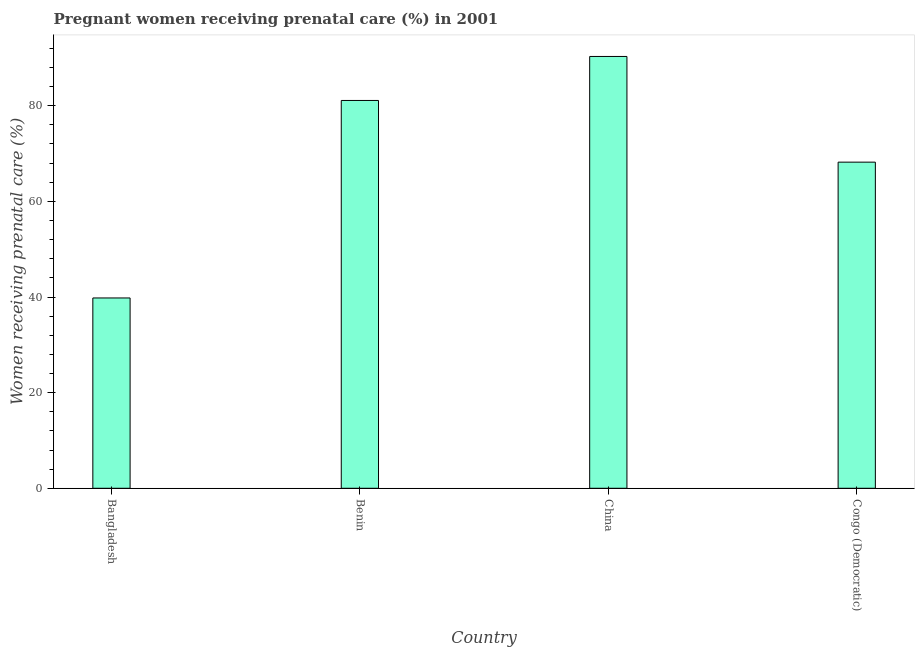What is the title of the graph?
Your response must be concise. Pregnant women receiving prenatal care (%) in 2001. What is the label or title of the X-axis?
Give a very brief answer. Country. What is the label or title of the Y-axis?
Provide a short and direct response. Women receiving prenatal care (%). What is the percentage of pregnant women receiving prenatal care in China?
Provide a succinct answer. 90.3. Across all countries, what is the maximum percentage of pregnant women receiving prenatal care?
Keep it short and to the point. 90.3. Across all countries, what is the minimum percentage of pregnant women receiving prenatal care?
Offer a very short reply. 39.8. In which country was the percentage of pregnant women receiving prenatal care maximum?
Give a very brief answer. China. In which country was the percentage of pregnant women receiving prenatal care minimum?
Your response must be concise. Bangladesh. What is the sum of the percentage of pregnant women receiving prenatal care?
Give a very brief answer. 279.4. What is the difference between the percentage of pregnant women receiving prenatal care in Bangladesh and Congo (Democratic)?
Keep it short and to the point. -28.4. What is the average percentage of pregnant women receiving prenatal care per country?
Offer a terse response. 69.85. What is the median percentage of pregnant women receiving prenatal care?
Offer a very short reply. 74.65. In how many countries, is the percentage of pregnant women receiving prenatal care greater than 76 %?
Give a very brief answer. 2. What is the ratio of the percentage of pregnant women receiving prenatal care in China to that in Congo (Democratic)?
Keep it short and to the point. 1.32. What is the difference between the highest and the second highest percentage of pregnant women receiving prenatal care?
Provide a succinct answer. 9.2. What is the difference between the highest and the lowest percentage of pregnant women receiving prenatal care?
Give a very brief answer. 50.5. How many countries are there in the graph?
Make the answer very short. 4. Are the values on the major ticks of Y-axis written in scientific E-notation?
Provide a short and direct response. No. What is the Women receiving prenatal care (%) in Bangladesh?
Ensure brevity in your answer.  39.8. What is the Women receiving prenatal care (%) in Benin?
Give a very brief answer. 81.1. What is the Women receiving prenatal care (%) in China?
Provide a succinct answer. 90.3. What is the Women receiving prenatal care (%) of Congo (Democratic)?
Offer a terse response. 68.2. What is the difference between the Women receiving prenatal care (%) in Bangladesh and Benin?
Your response must be concise. -41.3. What is the difference between the Women receiving prenatal care (%) in Bangladesh and China?
Your response must be concise. -50.5. What is the difference between the Women receiving prenatal care (%) in Bangladesh and Congo (Democratic)?
Provide a short and direct response. -28.4. What is the difference between the Women receiving prenatal care (%) in Benin and Congo (Democratic)?
Ensure brevity in your answer.  12.9. What is the difference between the Women receiving prenatal care (%) in China and Congo (Democratic)?
Offer a terse response. 22.1. What is the ratio of the Women receiving prenatal care (%) in Bangladesh to that in Benin?
Keep it short and to the point. 0.49. What is the ratio of the Women receiving prenatal care (%) in Bangladesh to that in China?
Keep it short and to the point. 0.44. What is the ratio of the Women receiving prenatal care (%) in Bangladesh to that in Congo (Democratic)?
Ensure brevity in your answer.  0.58. What is the ratio of the Women receiving prenatal care (%) in Benin to that in China?
Your answer should be compact. 0.9. What is the ratio of the Women receiving prenatal care (%) in Benin to that in Congo (Democratic)?
Your response must be concise. 1.19. What is the ratio of the Women receiving prenatal care (%) in China to that in Congo (Democratic)?
Make the answer very short. 1.32. 